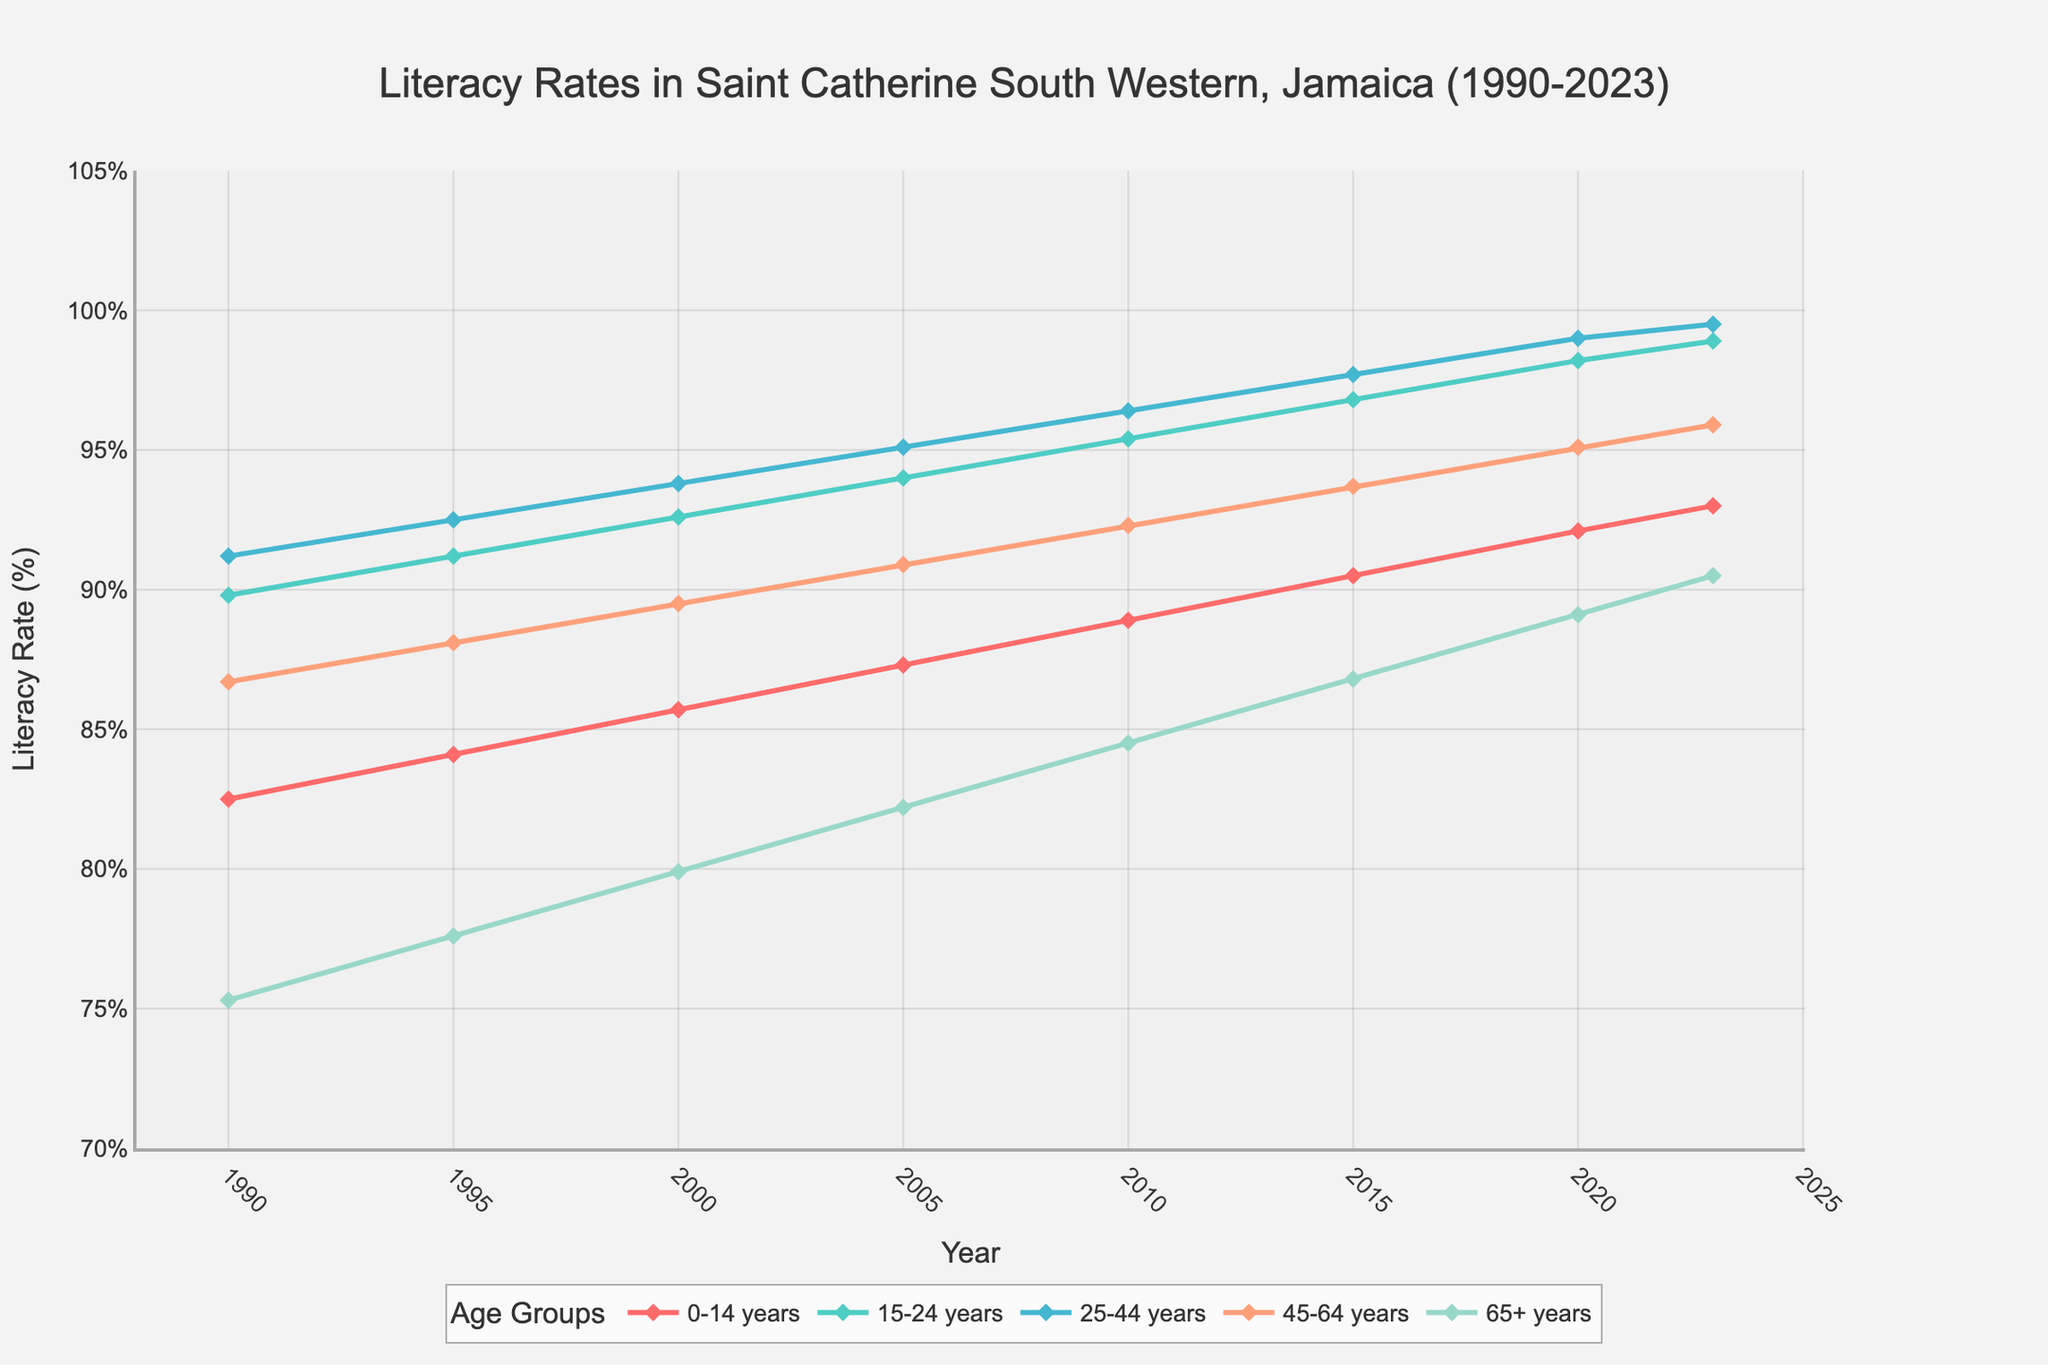What age group showed the highest increase in literacy rate between 1990 and 2023? To determine this, look at the literacy rates in 1990 and 2023 for each age group, then calculate the increase by subtracting the 1990 value from the 2023 value for each group. The highest increase is the largest of these differences.
Answer: 0-14 years How did the literacy rate for the 45-64 age group change from 1990 to 2023 compared to the 65+ age group? Compare the literacy rates in 1990 and 2023 for both the 45-64 and 65+ age groups. For the 45-64 group, it increased from 86.7% to 95.9%, an increase of 9.2 percentage points. For the 65+ group, it increased from 75.3% to 90.5%, an increase of 15.2 percentage points. Hence, the 65+ group had a larger increase.
Answer: The 65+ age group had a larger increase What was the average literacy rate for the 15-24 age group from 1990 to 2023? Find the sum of the literacy rates for the 15-24 age group across all years and then divide by the number of data points (8 years). Sum: 89.8 + 91.2 + 92.6 + 94.0 + 95.4 + 96.8 + 98.2 + 98.9 = 756.9, Average = 756.9 / 8 = 94.6125
Answer: 94.6% Which year did the 25-44 age group first exceed a 95% literacy rate? Observe the literacy rates for the 25-44 age group across the years. The rate first exceeds 95% in 2005, reaching 95.1%.
Answer: 2005 Among all age groups, which one had the lowest literacy rate in 1995? Look at the literacy rates for all age groups in 1995. The 65+ age group had the lowest literacy rate at 77.6%.
Answer: 65+ years What is the difference between the literacy rates of the 25-44 and 45-64 age groups in 2023? Subtract the literacy rate of the 45-64 age group from the 25-44 age group in 2023. 99.5% - 95.9% = 3.6%
Answer: 3.6% How many age groups had a literacy rate of over 90% in the year 2000? Identify the literacy rates for all age groups in the year 2000 and count those with rates over 90%. Age groups: 15-24 (92.6%), 25-44 (93.8%), and 45-64 (89.5%), 0-14 (85.7%), 65+ (79.9%). Only the 15-24 and 25-44 groups are over 90%.
Answer: 2 Which age group shows a consistent increase in literacy rate across all recorded years? Check the literacy rates across all years for each age group to determine which ones continually increased without any decrease. All age groups show consistent increases in literacy rates.
Answer: All age groups Between 1990 and 2023, which year saw the largest increase in literacy rate for the 0-14 age group as compared to the previous recorded year? Calculate the difference in literacy rates for the 0-14 age group between consecutive years and identify the year with the largest increase. Largest increase: 2.5% from 2000 to 2005 (87.3% - 85.7%).
Answer: 2005 